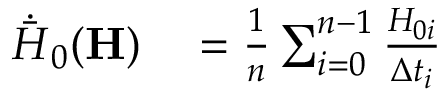<formula> <loc_0><loc_0><loc_500><loc_500>\begin{array} { r l } { \dot { \bar { H } } _ { 0 } ( H ) } & = \frac { 1 } { n } \sum _ { i = 0 } ^ { n - 1 } \frac { H _ { 0 i } } { \Delta t _ { i } } } \end{array}</formula> 